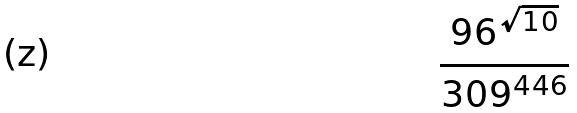Convert formula to latex. <formula><loc_0><loc_0><loc_500><loc_500>\frac { 9 6 ^ { \sqrt { 1 0 } } } { 3 0 9 ^ { 4 4 6 } }</formula> 